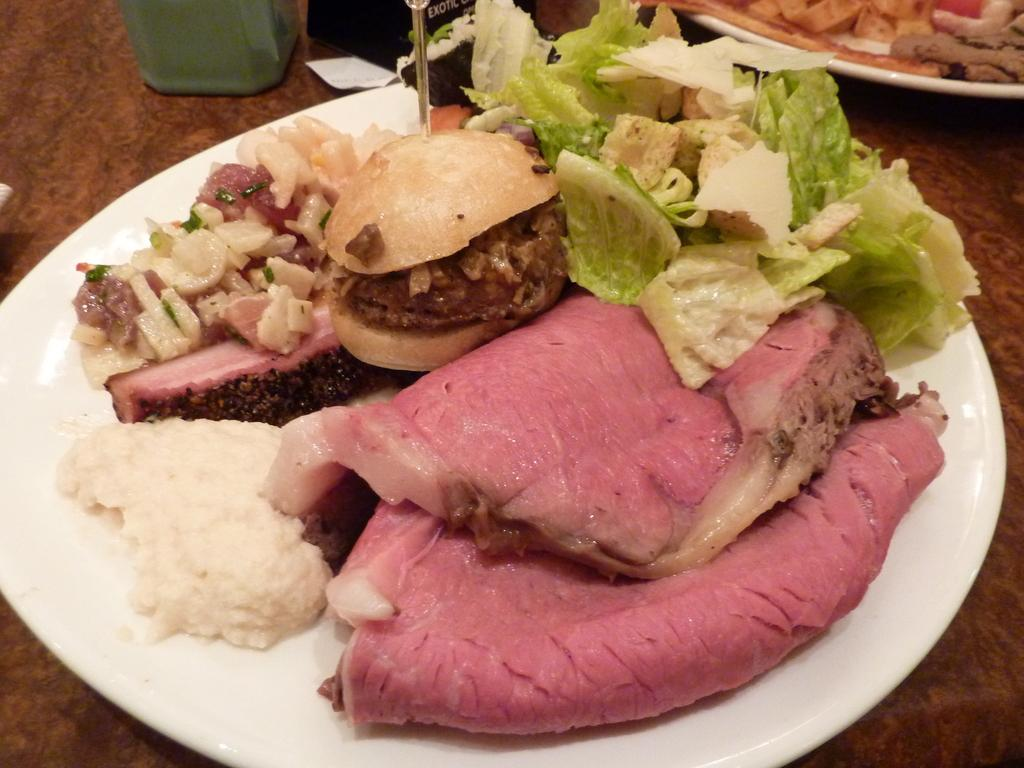What is present on the brown table in the image? There are two plates containing food items, green-colored objects, and black-colored objects on the brown table. What type of food items can be seen on the plates? The specific food items cannot be determined from the provided facts. What color are the plates? The color of the plates is not mentioned in the provided facts. What is the tax rate on the food items in the image? There is no information about tax rates in the image or the provided facts. What type of desk is visible in the image? There is no desk present in the image. 